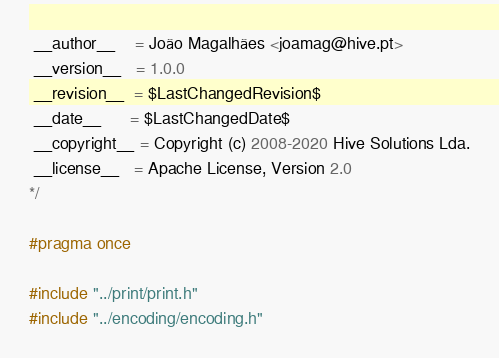Convert code to text. <code><loc_0><loc_0><loc_500><loc_500><_C_>
 __author__    = João Magalhães <joamag@hive.pt>
 __version__   = 1.0.0
 __revision__  = $LastChangedRevision$
 __date__      = $LastChangedDate$
 __copyright__ = Copyright (c) 2008-2020 Hive Solutions Lda.
 __license__   = Apache License, Version 2.0
*/

#pragma once

#include "../print/print.h"
#include "../encoding/encoding.h"
</code> 